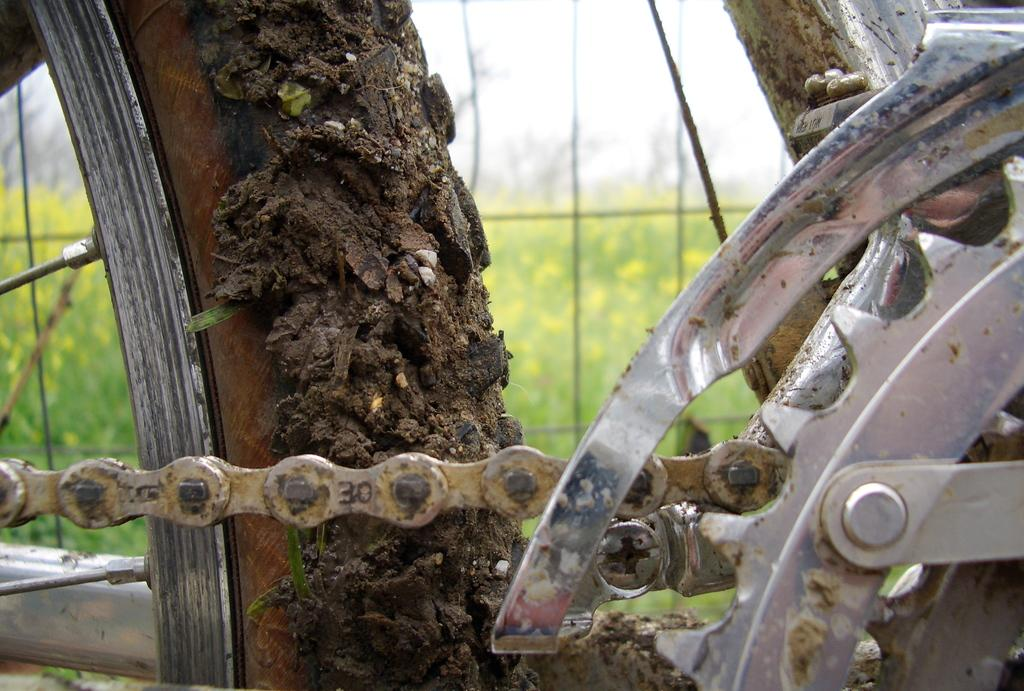What type of object can be seen in the image related to a bicycle? There is a bicycle chain in the image. What other part of a bicycle is visible in the image? There is a wheel in the image. What type of list can be seen in the image? There is no list present in the image. Is there an umbrella being used to stop the wheel in the image? There is no umbrella or any object being used to stop the wheel in the image. 